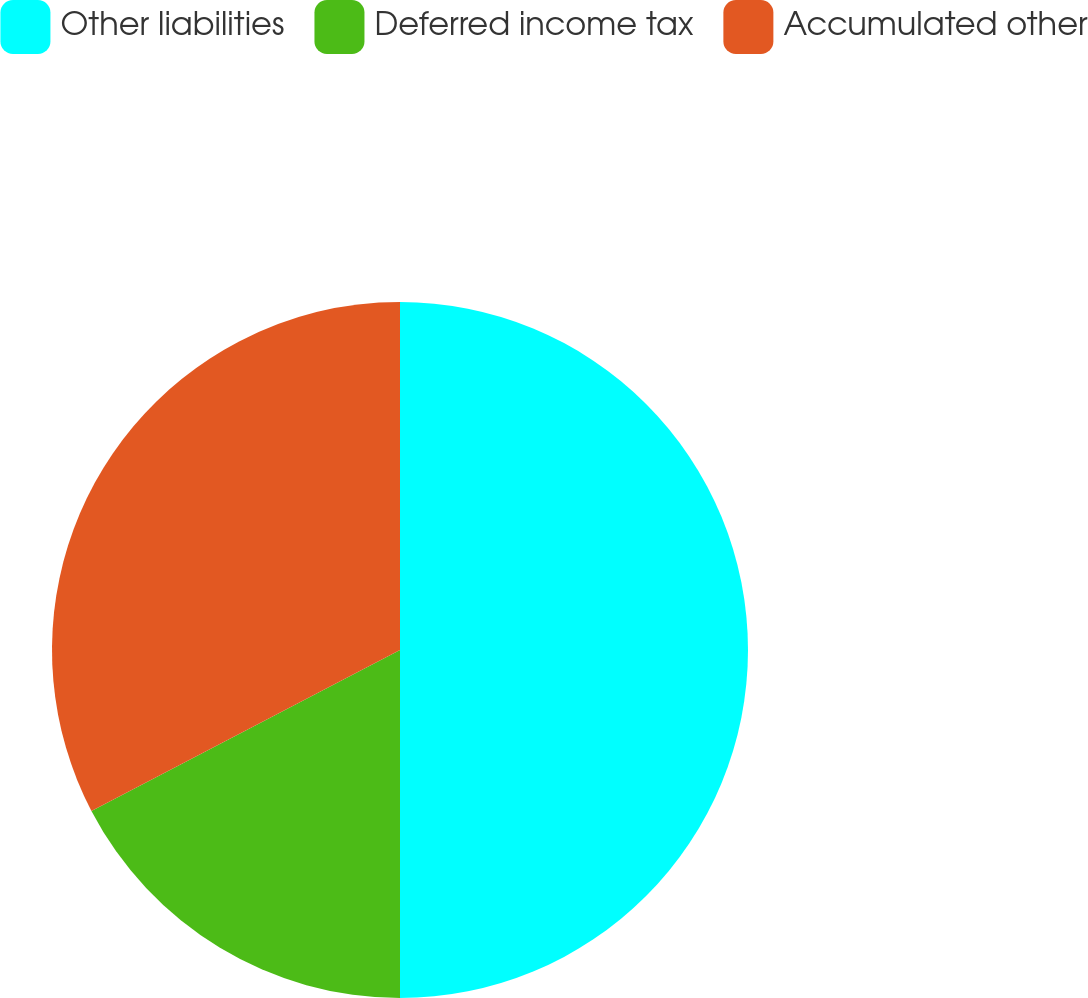<chart> <loc_0><loc_0><loc_500><loc_500><pie_chart><fcel>Other liabilities<fcel>Deferred income tax<fcel>Accumulated other<nl><fcel>50.0%<fcel>17.35%<fcel>32.65%<nl></chart> 